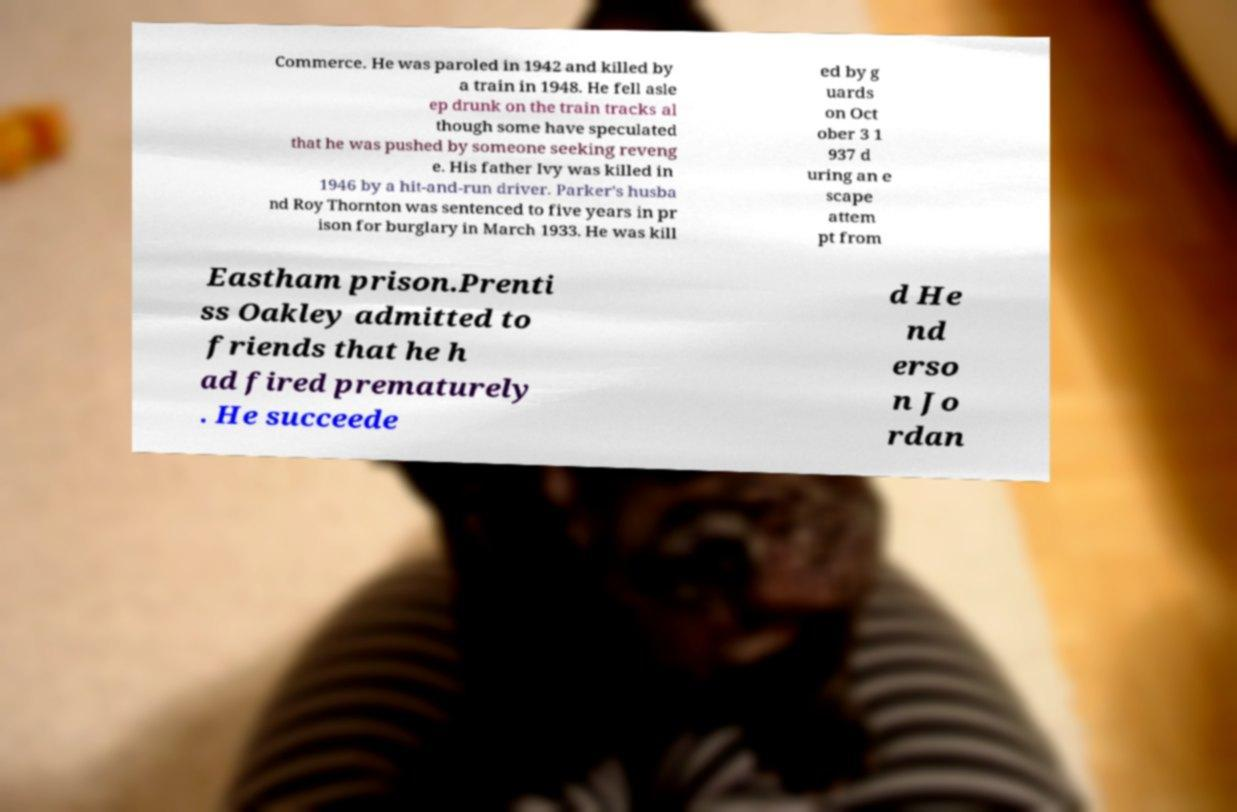I need the written content from this picture converted into text. Can you do that? Commerce. He was paroled in 1942 and killed by a train in 1948. He fell asle ep drunk on the train tracks al though some have speculated that he was pushed by someone seeking reveng e. His father Ivy was killed in 1946 by a hit-and-run driver. Parker's husba nd Roy Thornton was sentenced to five years in pr ison for burglary in March 1933. He was kill ed by g uards on Oct ober 3 1 937 d uring an e scape attem pt from Eastham prison.Prenti ss Oakley admitted to friends that he h ad fired prematurely . He succeede d He nd erso n Jo rdan 